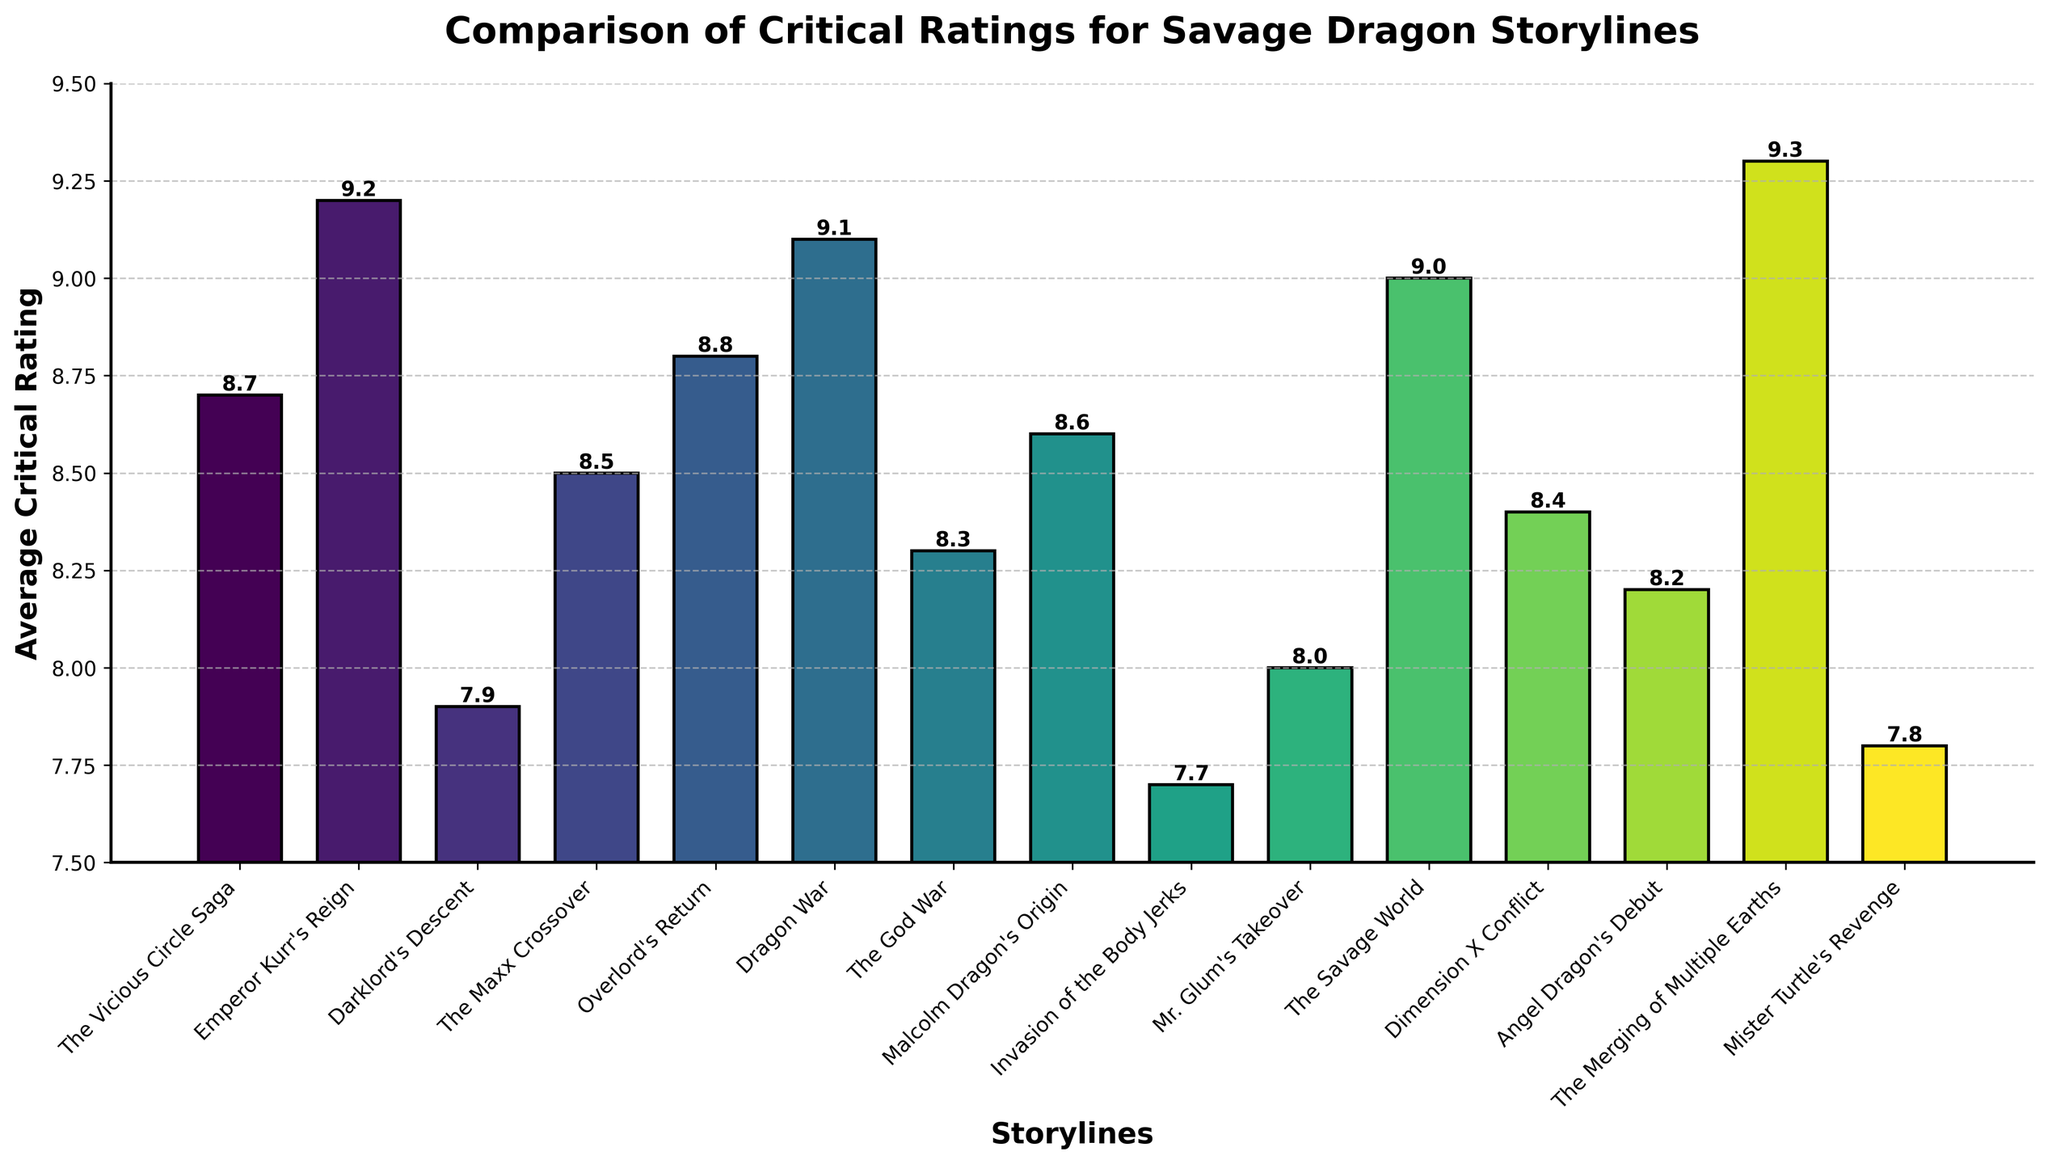Which storyline received the highest average critical rating? The storyline with the highest bar on the chart represents the highest average critical rating. "The Merging of Multiple Earths" has the highest bar.
Answer: The Merging of Multiple Earths Which storyline received the lowest average critical rating? The storyline with the shortest bar on the chart represents the lowest average critical rating. "Invasion of the Body Jerks" has the shortest bar.
Answer: Invasion of the Body Jerks How much higher is the rating of "Emperor Kurr's Reign" compared to "Darklord's Descent"? To find the difference in ratings, we calculate 9.2 (Emperor Kurr's Reign) - 7.9 (Darklord's Descent). The difference is 1.3.
Answer: 1.3 Are there any storylines with an average rating of exactly 8.0? Check for bars that align with the rating of 8.0 on the y-axis. "Mr. Glum's Takeover" has an average rating of 8.0.
Answer: Mr. Glum's Takeover What is the average rating of the three storylines with the highest ratings? The three highest ratings are 9.3 ("The Merging of Multiple Earths"), 9.2 ("Emperor Kurr's Reign"), and 9.1 ("Dragon War"). The average is calculated as (9.3 + 9.2 + 9.1) / 3 = 9.2.
Answer: 9.2 Which storyline has a higher average rating, "The Savage World" or "Overlord's Return"? Compare the heights of the bars for "The Savage World" (9.0) and "Overlord's Return" (8.8). "The Savage World" has a higher rating.
Answer: The Savage World Which storylines have an average rating between 8.0 and 8.5? Identify bars within the range of 8.0 to 8.5 on the y-axis. The storylines are "The Maxx Crossover" (8.5), "Mr. Glum's Takeover" (8.0), and "Dimension X Conflict" (8.4).
Answer: The Maxx Crossover, Dimension X Conflict, Mr. Glum's Takeover Is the average rating of "Angel Dragon's Debut" higher or lower than "The God War"? Compare the bars for "Angel Dragon's Debut" (8.2) and "The God War" (8.3). "Angel Dragon's Debut" has a lower rating.
Answer: Lower What is the combined average rating of "Malcolm Dragon's Origin" and "Mister Turtle's Revenge"? Add the ratings of "Malcolm Dragon's Origin" (8.6) and "Mister Turtle's Revenge" (7.8). The combined rating is 8.6 + 7.8 = 16.4.
Answer: 16.4 How many storylines have an average rating higher than 8.5? Count the number of bars with heights exceeding 8.5 on the y-axis. They are: "Emperor Kurr's Reign" (9.2), "Overlord's Return" (8.8), "Dragon War" (9.1), "The Savage World" (9.0), and "The Merging of Multiple Earths" (9.3), totaling 5.
Answer: 5 